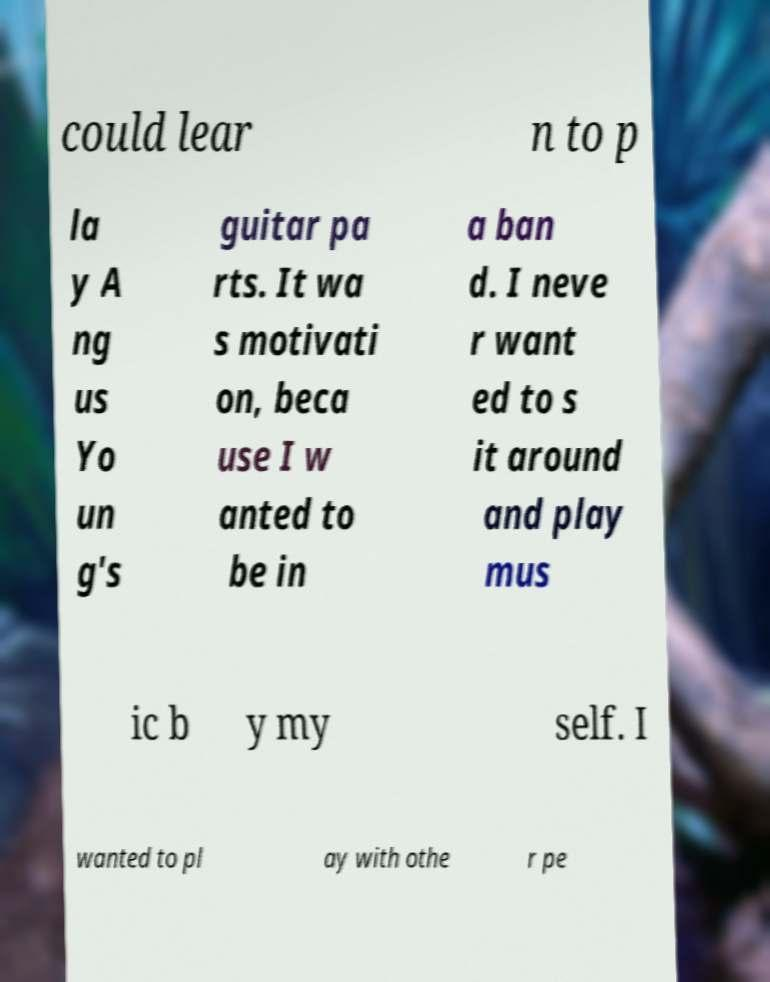I need the written content from this picture converted into text. Can you do that? could lear n to p la y A ng us Yo un g's guitar pa rts. It wa s motivati on, beca use I w anted to be in a ban d. I neve r want ed to s it around and play mus ic b y my self. I wanted to pl ay with othe r pe 